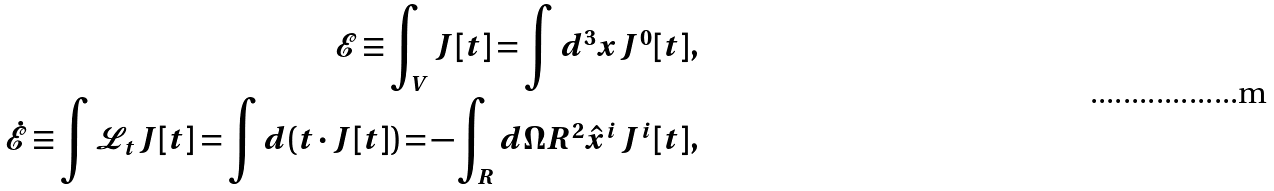Convert formula to latex. <formula><loc_0><loc_0><loc_500><loc_500>\mathcal { E } \equiv \int _ { V } J [ t ] = \int d ^ { 3 } x J ^ { 0 } [ t ] , \\ \dot { \mathcal { E } } \equiv \int \mathcal { L } _ { t } J [ t ] = \int d ( t \cdot J [ t ] ) = - \int _ { R } d \Omega R ^ { 2 } \hat { x } ^ { i } J ^ { i } [ t ] ,</formula> 